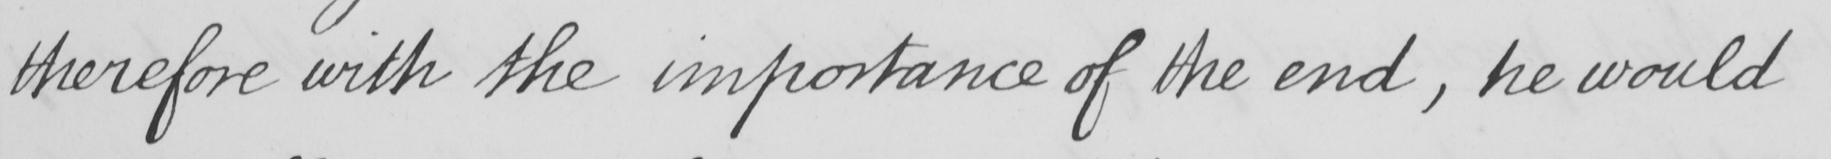What text is written in this handwritten line? therefore with the importance of the end , he would 